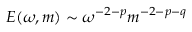Convert formula to latex. <formula><loc_0><loc_0><loc_500><loc_500>E ( \omega , m ) \sim \omega ^ { - 2 - p } m ^ { - 2 - p - q }</formula> 